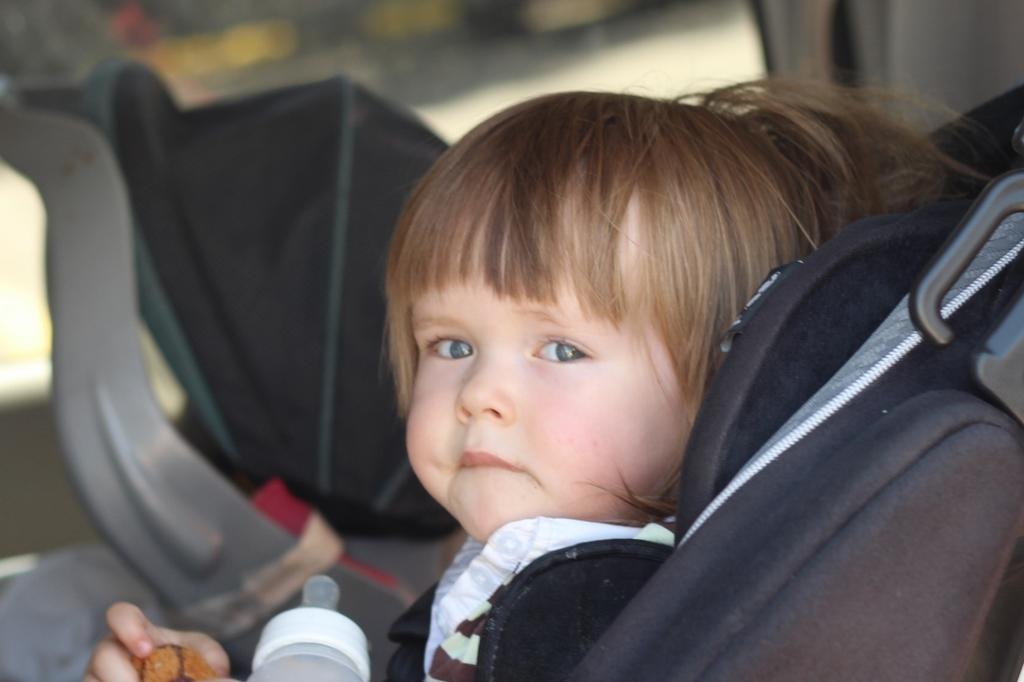Could you give a brief overview of what you see in this image? In this image I can see a baby sitting on the seat or on a chair. And the baby is holding an object, also there is a baby sipper. There are some objects and the background is blurry. 